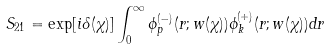Convert formula to latex. <formula><loc_0><loc_0><loc_500><loc_500>S _ { 2 1 } = \exp [ i \delta ( \chi ) ] \int _ { 0 } ^ { \infty } \phi ^ { ( - ) } _ { p } ( r ; w ( \chi ) ) \phi ^ { ( + ) } _ { k } ( r ; w ( \chi ) ) d r</formula> 